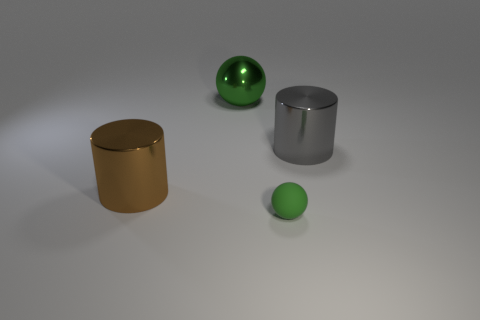There is a big object that is left of the rubber ball and to the right of the large brown shiny cylinder; what color is it? green 